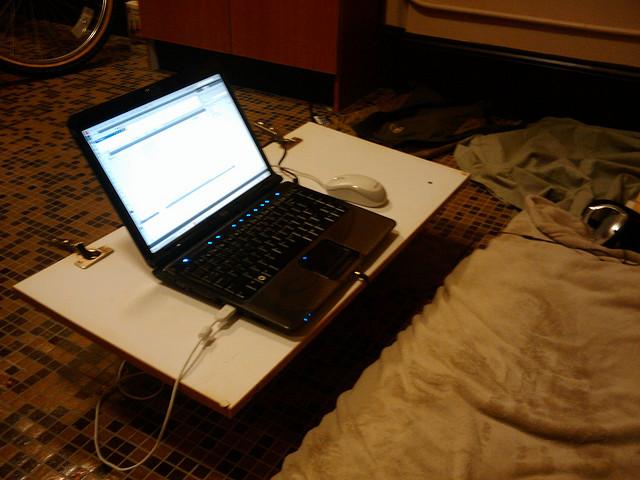What color is the bedding?
Keep it brief. Beige. How many suitcases have locks on them?
Be succinct. 0. Is the laptop computer turned on or shut off?
Answer briefly. On. What type of floor is this?
Give a very brief answer. Tile. What color is the computer?
Short answer required. Black. Is the laptop plugged in?
Concise answer only. Yes. Is there a mode of transportation in the picture?
Concise answer only. No. 